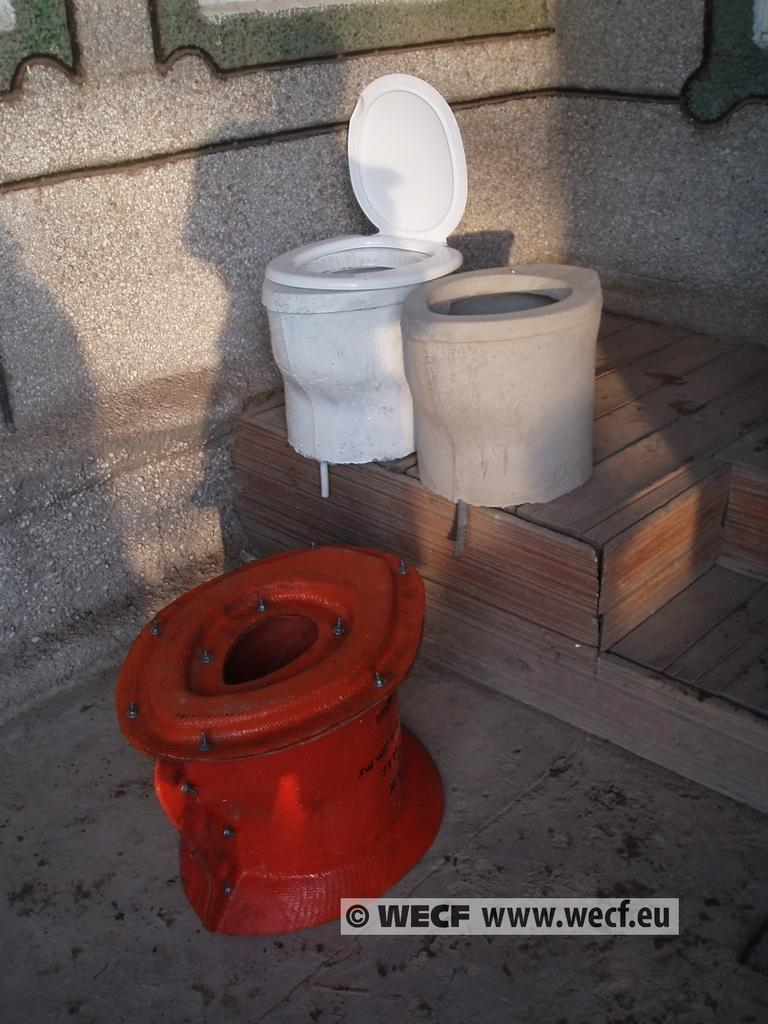<image>
Render a clear and concise summary of the photo. Three toilets in different colors and different shapes are outside with a copyright of WECF. 